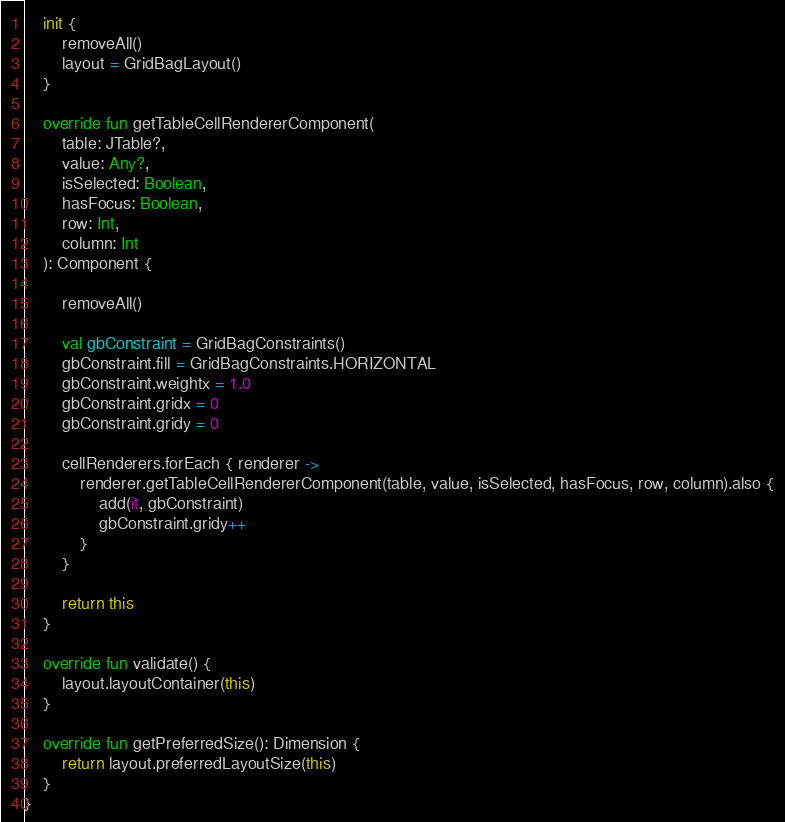<code> <loc_0><loc_0><loc_500><loc_500><_Kotlin_>    init {
        removeAll()
        layout = GridBagLayout()
    }

    override fun getTableCellRendererComponent(
        table: JTable?,
        value: Any?,
        isSelected: Boolean,
        hasFocus: Boolean,
        row: Int,
        column: Int
    ): Component {

        removeAll()

        val gbConstraint = GridBagConstraints()
        gbConstraint.fill = GridBagConstraints.HORIZONTAL
        gbConstraint.weightx = 1.0
        gbConstraint.gridx = 0
        gbConstraint.gridy = 0

        cellRenderers.forEach { renderer ->
            renderer.getTableCellRendererComponent(table, value, isSelected, hasFocus, row, column).also {
                add(it, gbConstraint)
                gbConstraint.gridy++
            }
        }

        return this
    }

    override fun validate() {
        layout.layoutContainer(this)
    }

    override fun getPreferredSize(): Dimension {
        return layout.preferredLayoutSize(this)
    }
}</code> 